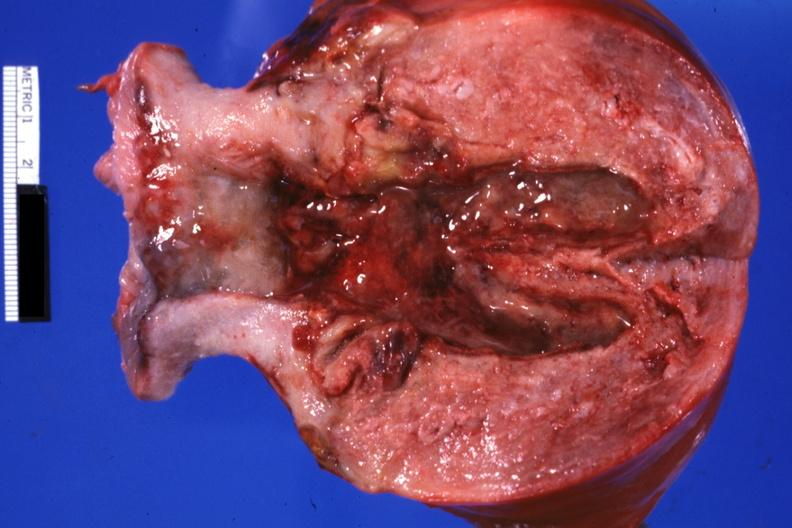what does this image show?
Answer the question using a single word or phrase. Opened cervix and endometrium with necrotic tissue five weeks post section because of brain hemorrhage 40 weeks gestation 29 yo hypertensive bf 